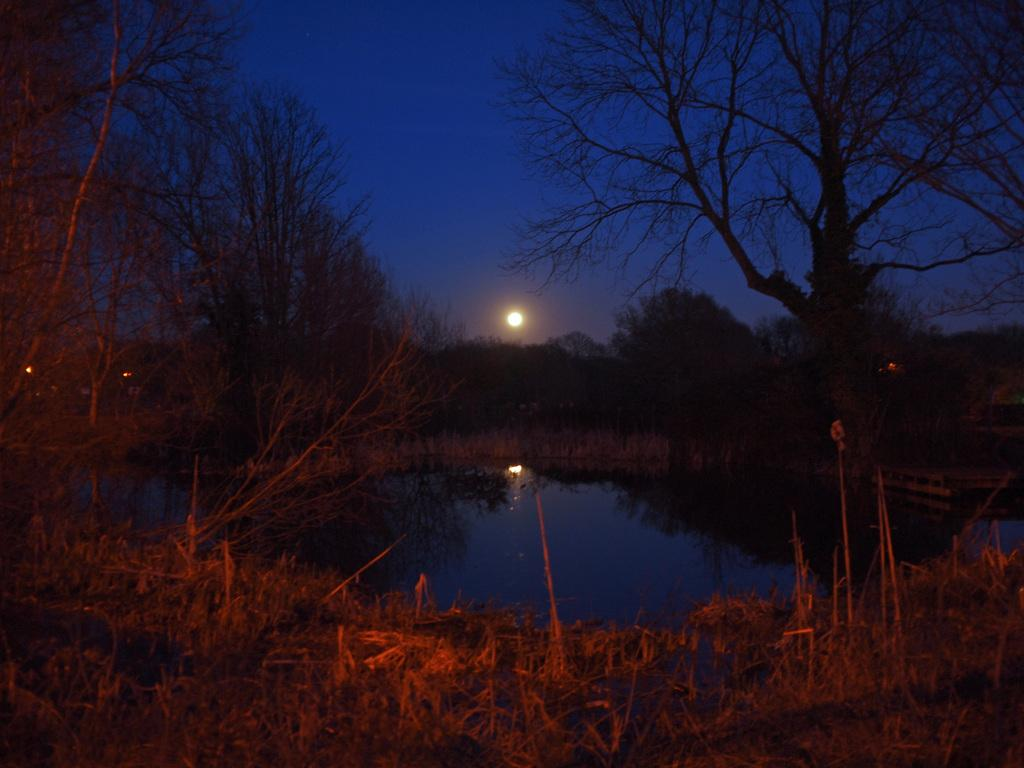What natural elements can be seen in the image? Water, grass, trees, and plants are visible in the image. What part of the sky is visible in the image? The sky is visible in the image, and the moon is also visible. What type of vegetation is present in the image? Trees and plants are present in the image. What type of sponge is being used to clean the boot in the image? There is no sponge or boot present in the image. What cast member from a popular TV show can be seen in the image? There are no cast members or TV shows mentioned in the image. 